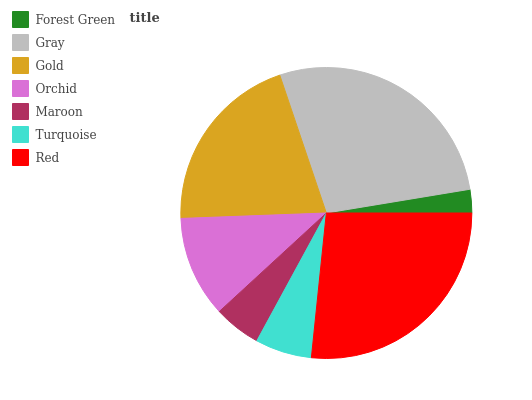Is Forest Green the minimum?
Answer yes or no. Yes. Is Gray the maximum?
Answer yes or no. Yes. Is Gold the minimum?
Answer yes or no. No. Is Gold the maximum?
Answer yes or no. No. Is Gray greater than Gold?
Answer yes or no. Yes. Is Gold less than Gray?
Answer yes or no. Yes. Is Gold greater than Gray?
Answer yes or no. No. Is Gray less than Gold?
Answer yes or no. No. Is Orchid the high median?
Answer yes or no. Yes. Is Orchid the low median?
Answer yes or no. Yes. Is Maroon the high median?
Answer yes or no. No. Is Forest Green the low median?
Answer yes or no. No. 